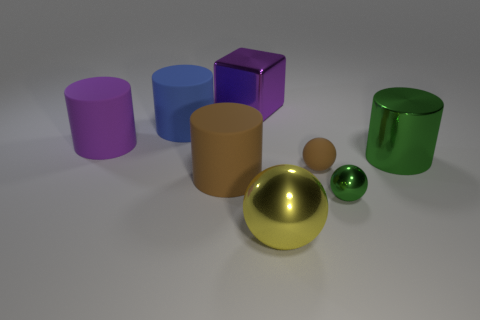How many cylinders are to the left of the large brown object? To the left of the large brown cylindrical object, there are two cylinders. The closest to the brown one is violet, while the other is blue. 